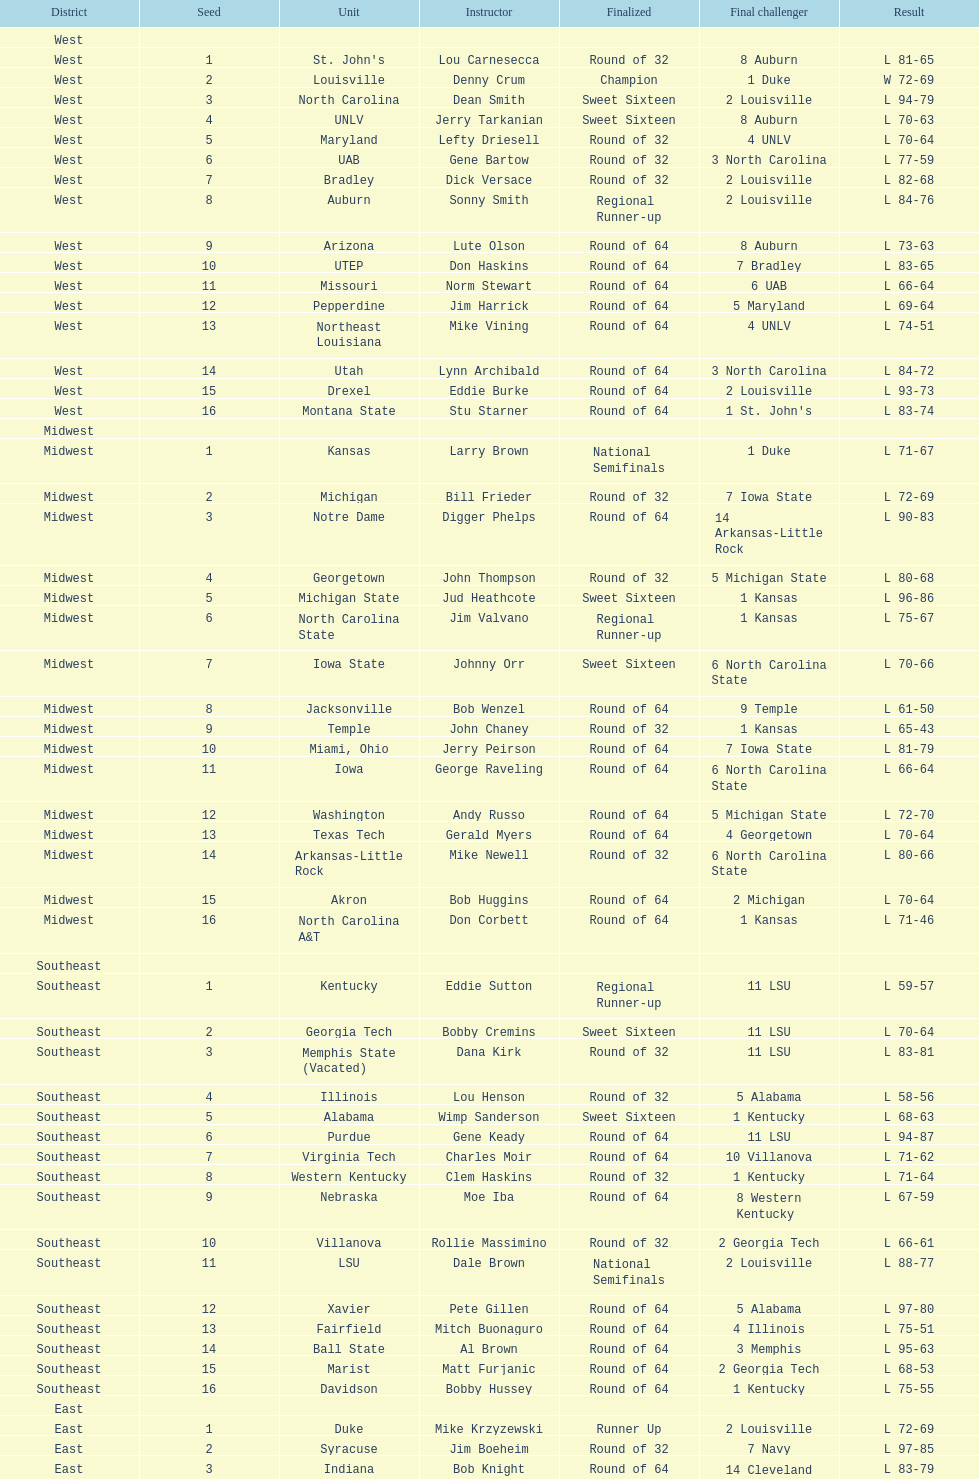How many number of teams played altogether? 64. 